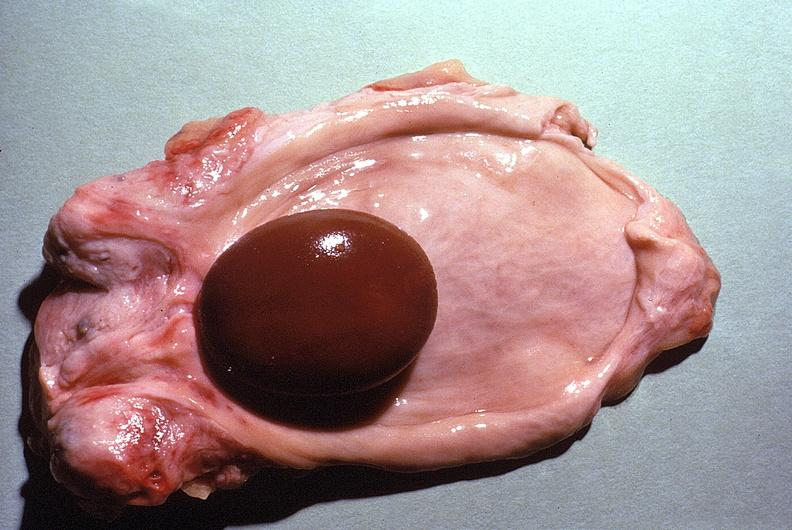what is present?
Answer the question using a single word or phrase. Urinary 